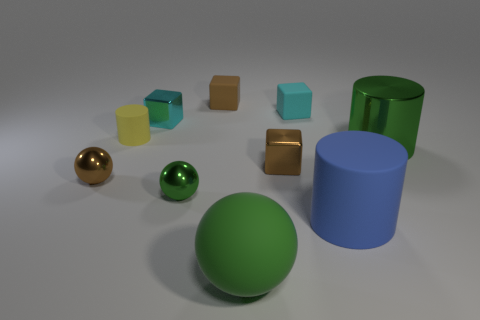Subtract 1 blocks. How many blocks are left? 3 Subtract all green cylinders. Subtract all brown spheres. How many cylinders are left? 2 Subtract all cylinders. How many objects are left? 7 Add 4 big objects. How many big objects exist? 7 Subtract 0 brown cylinders. How many objects are left? 10 Subtract all big brown matte balls. Subtract all brown rubber things. How many objects are left? 9 Add 3 large green objects. How many large green objects are left? 5 